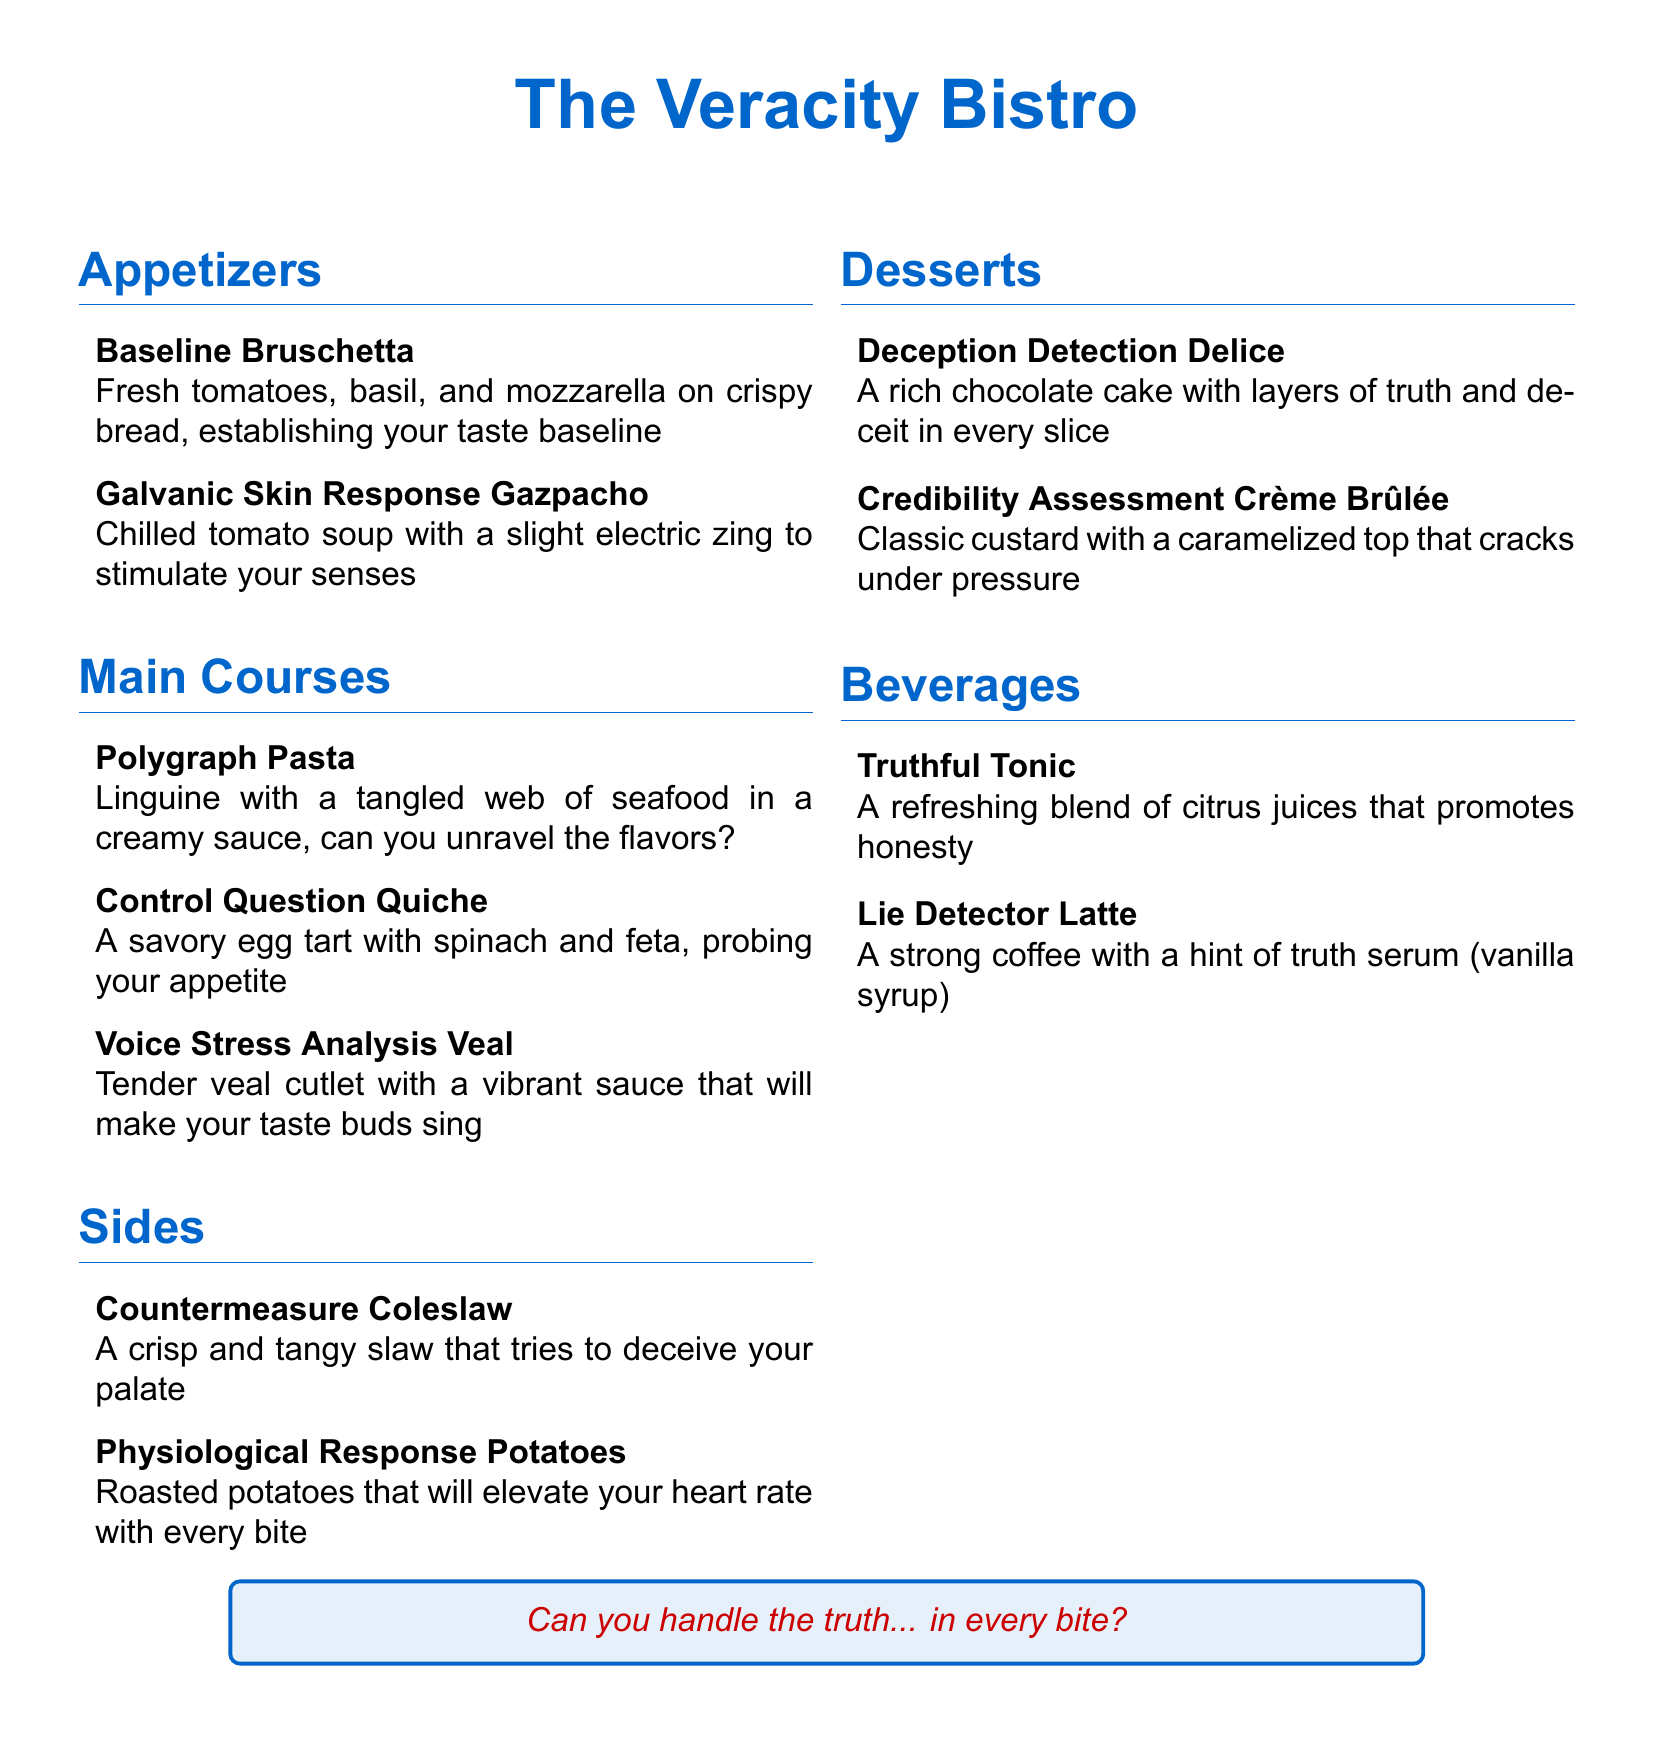What is the name of the restaurant? The title at the top of the menu indicates the restaurant's name.
Answer: The Veracity Bistro How many appetizers are listed on the menu? The appetizers section contains two items, which can be counted directly from the list.
Answer: 2 What is in the Control Question Quiche? The description of the Control Question Quiche specifies its ingredients.
Answer: Spinach and feta What dish represents a physiological response? The item in the sides section that suggests a physiological response is explicitly named.
Answer: Physiological Response Potatoes Which dessert is described as rich chocolate cake? The dessert section mentions a specific cake with rich chocolate in the title.
Answer: Deception Detection Delice What beverage promotes honesty? The menu includes a beverage that is described as refreshing and promotes honesty.
Answer: Truthful Tonic Which main course features seafood? The main courses section contains one dish that explicitly mentions seafood.
Answer: Polygraph Pasta What technique does the Lie Detector Latte hint at? The description of the beverage suggests a connection to the concept of truth through its flavor.
Answer: Truth serum (vanilla syrup) What is the characteristic of the Credibility Assessment Crème Brûlée? The portion of the menu describing this dessert provides its unique feature related to its texture.
Answer: Cracks under pressure 